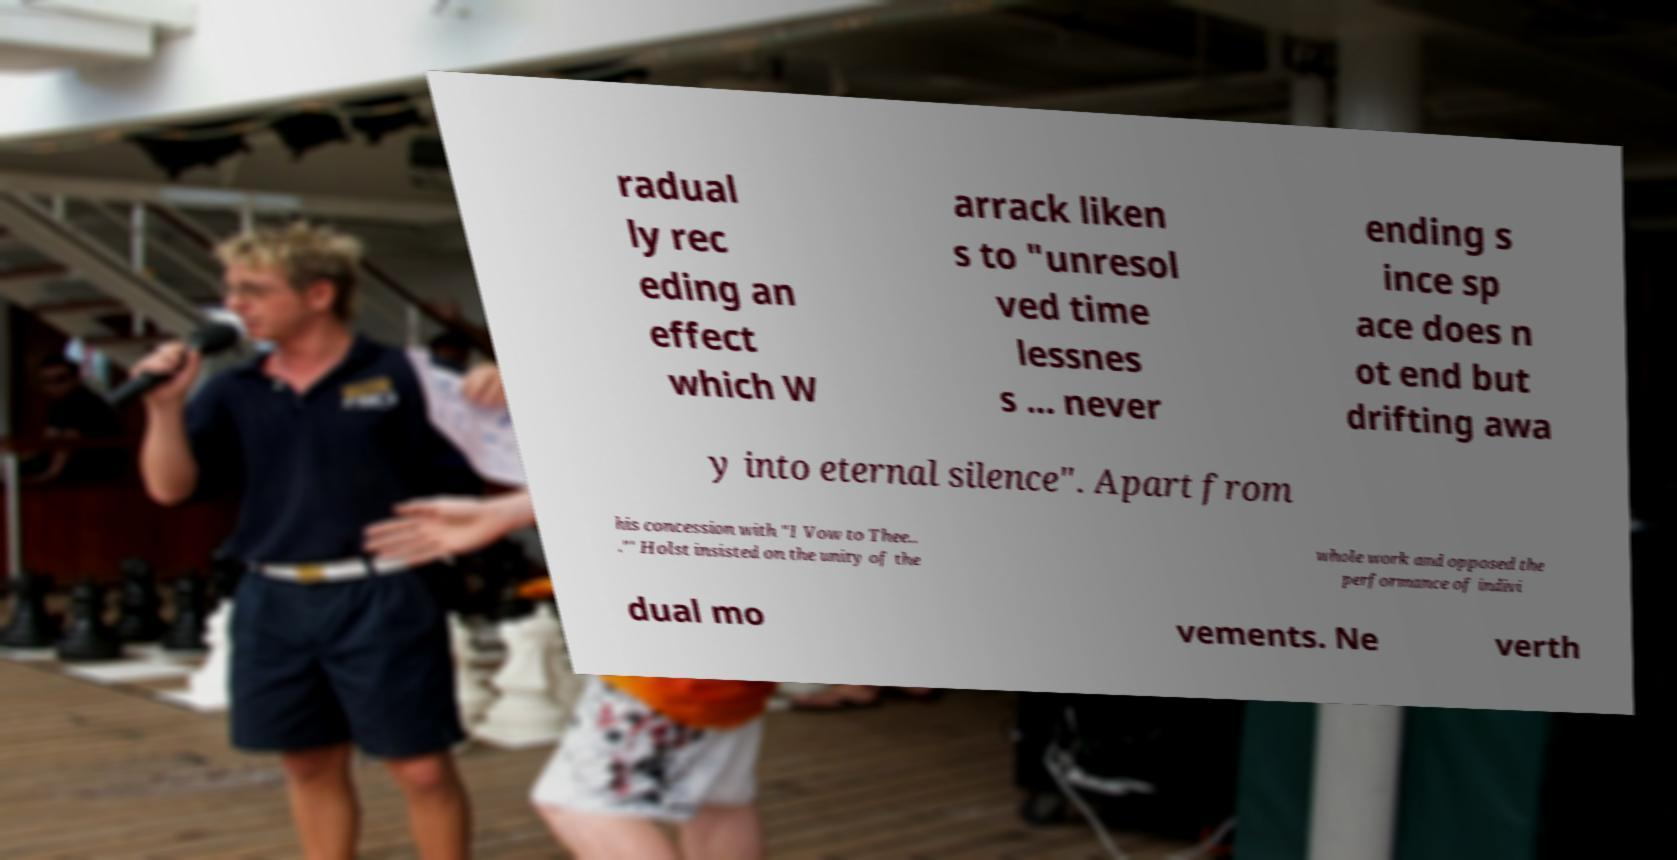Please read and relay the text visible in this image. What does it say? radual ly rec eding an effect which W arrack liken s to "unresol ved time lessnes s ... never ending s ince sp ace does n ot end but drifting awa y into eternal silence". Apart from his concession with "I Vow to Thee.. ."' Holst insisted on the unity of the whole work and opposed the performance of indivi dual mo vements. Ne verth 